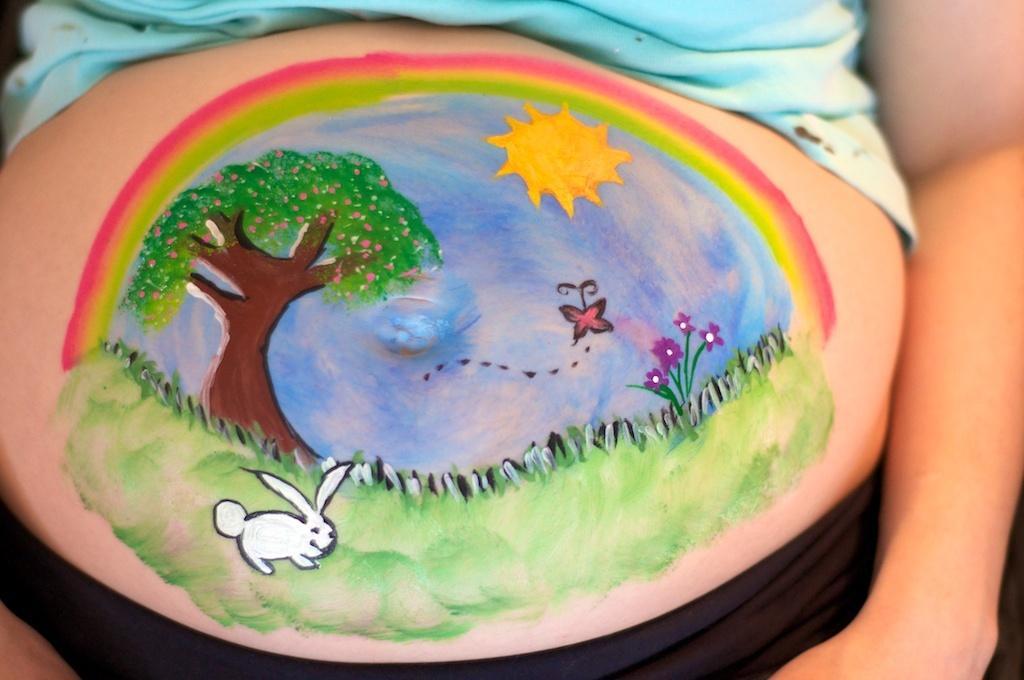Please provide a concise description of this image. As we can see in the image there is a person and drawing of grass, sky, butterfly, plant, flowers, tree, sun and rabbit. 